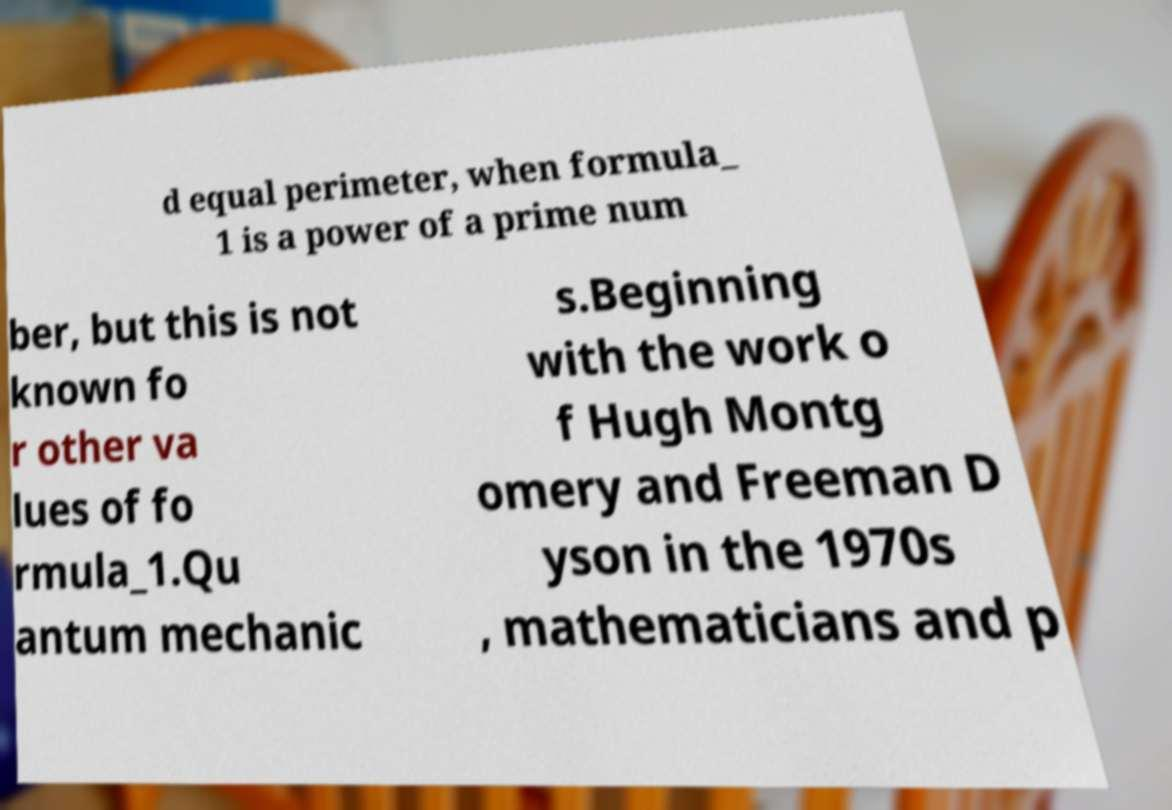What messages or text are displayed in this image? I need them in a readable, typed format. d equal perimeter, when formula_ 1 is a power of a prime num ber, but this is not known fo r other va lues of fo rmula_1.Qu antum mechanic s.Beginning with the work o f Hugh Montg omery and Freeman D yson in the 1970s , mathematicians and p 